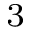Convert formula to latex. <formula><loc_0><loc_0><loc_500><loc_500>_ { 3 }</formula> 